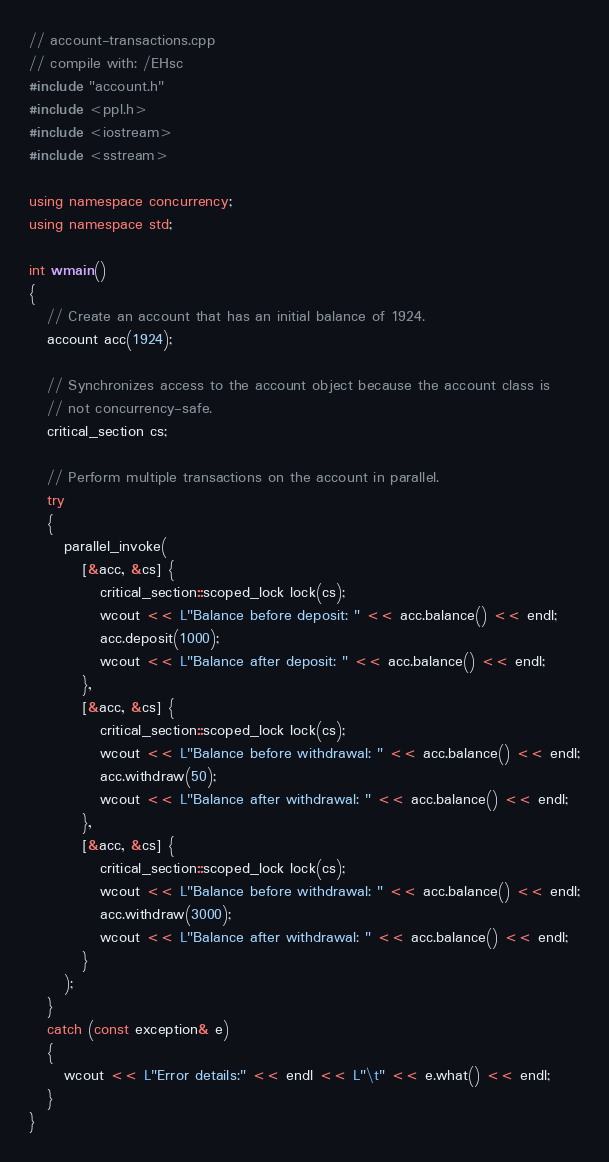Convert code to text. <code><loc_0><loc_0><loc_500><loc_500><_C++_>// account-transactions.cpp
// compile with: /EHsc
#include "account.h"
#include <ppl.h>
#include <iostream>
#include <sstream>

using namespace concurrency;
using namespace std;

int wmain()
{
   // Create an account that has an initial balance of 1924.
   account acc(1924);

   // Synchronizes access to the account object because the account class is 
   // not concurrency-safe.
   critical_section cs;

   // Perform multiple transactions on the account in parallel.   
   try
   {
      parallel_invoke(
         [&acc, &cs] {
            critical_section::scoped_lock lock(cs);
            wcout << L"Balance before deposit: " << acc.balance() << endl;
            acc.deposit(1000);
            wcout << L"Balance after deposit: " << acc.balance() << endl;
         },
         [&acc, &cs] {
            critical_section::scoped_lock lock(cs);
            wcout << L"Balance before withdrawal: " << acc.balance() << endl;
            acc.withdraw(50);
            wcout << L"Balance after withdrawal: " << acc.balance() << endl;
         },
         [&acc, &cs] {
            critical_section::scoped_lock lock(cs);
            wcout << L"Balance before withdrawal: " << acc.balance() << endl;
            acc.withdraw(3000);
            wcout << L"Balance after withdrawal: " << acc.balance() << endl;
         }
      );
   }
   catch (const exception& e)
   {
      wcout << L"Error details:" << endl << L"\t" << e.what() << endl;
   }
}</code> 